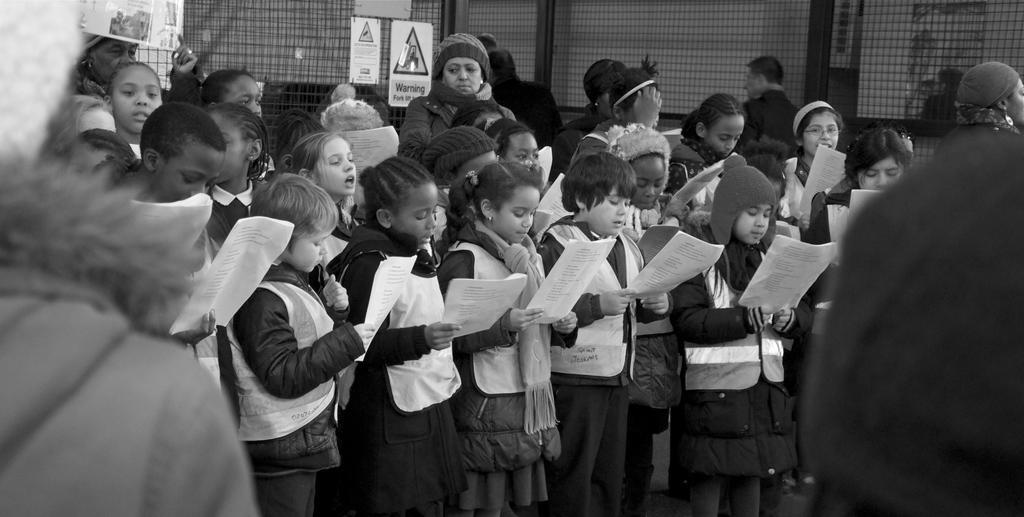In one or two sentences, can you explain what this image depicts? In the image few people are standing and holding some papers. Behind them there is fencing, on the fencing there are some banners and sign boards. Behind the fencing there is wall. 